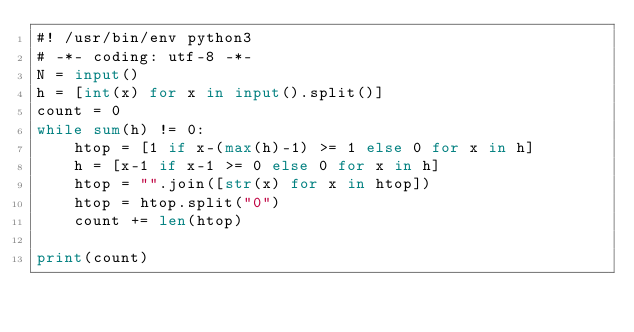<code> <loc_0><loc_0><loc_500><loc_500><_Python_>#! /usr/bin/env python3
# -*- coding: utf-8 -*-
N = input()
h = [int(x) for x in input().split()]
count = 0
while sum(h) != 0:
    htop = [1 if x-(max(h)-1) >= 1 else 0 for x in h]
    h = [x-1 if x-1 >= 0 else 0 for x in h]
    htop = "".join([str(x) for x in htop])
    htop = htop.split("0") 
    count += len(htop)

print(count)</code> 